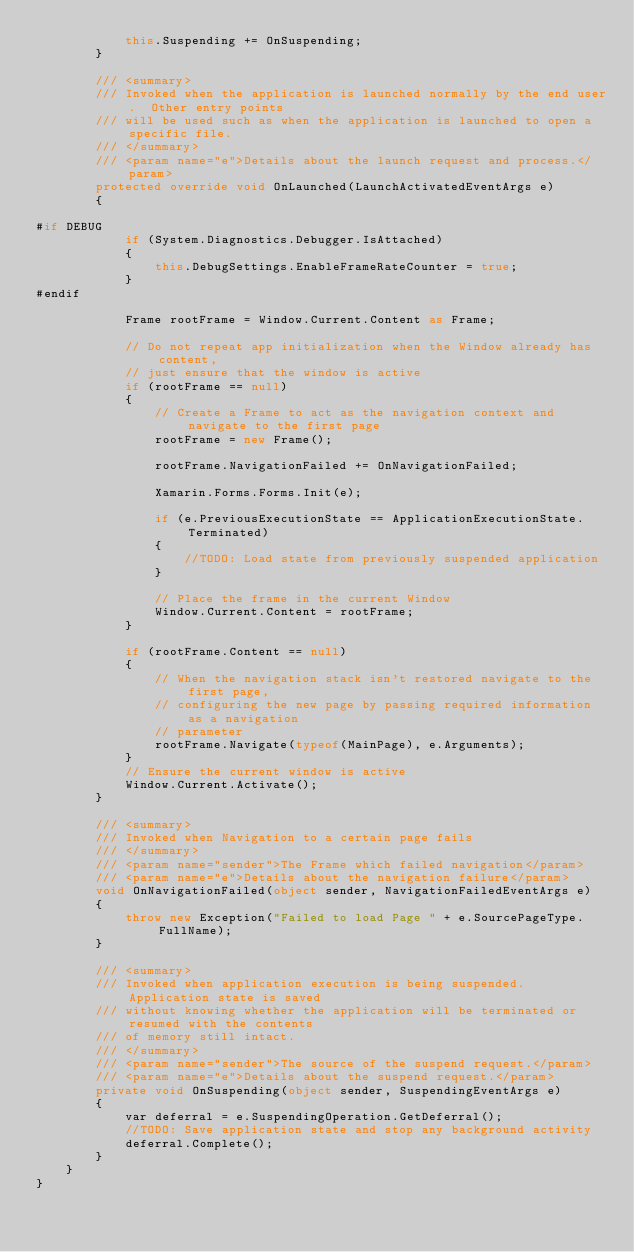Convert code to text. <code><loc_0><loc_0><loc_500><loc_500><_C#_>            this.Suspending += OnSuspending;
        }

        /// <summary>
        /// Invoked when the application is launched normally by the end user.  Other entry points
        /// will be used such as when the application is launched to open a specific file.
        /// </summary>
        /// <param name="e">Details about the launch request and process.</param>
        protected override void OnLaunched(LaunchActivatedEventArgs e)
        {

#if DEBUG
            if (System.Diagnostics.Debugger.IsAttached)
            {
                this.DebugSettings.EnableFrameRateCounter = true;
            }
#endif

            Frame rootFrame = Window.Current.Content as Frame;

            // Do not repeat app initialization when the Window already has content,
            // just ensure that the window is active
            if (rootFrame == null)
            {
                // Create a Frame to act as the navigation context and navigate to the first page
                rootFrame = new Frame();

                rootFrame.NavigationFailed += OnNavigationFailed;

                Xamarin.Forms.Forms.Init(e);

                if (e.PreviousExecutionState == ApplicationExecutionState.Terminated)
                {
                    //TODO: Load state from previously suspended application
                }

                // Place the frame in the current Window
                Window.Current.Content = rootFrame;
            }

            if (rootFrame.Content == null)
            {
                // When the navigation stack isn't restored navigate to the first page,
                // configuring the new page by passing required information as a navigation
                // parameter
                rootFrame.Navigate(typeof(MainPage), e.Arguments);
            }
            // Ensure the current window is active
            Window.Current.Activate();
        }

        /// <summary>
        /// Invoked when Navigation to a certain page fails
        /// </summary>
        /// <param name="sender">The Frame which failed navigation</param>
        /// <param name="e">Details about the navigation failure</param>
        void OnNavigationFailed(object sender, NavigationFailedEventArgs e)
        {
            throw new Exception("Failed to load Page " + e.SourcePageType.FullName);
        }

        /// <summary>
        /// Invoked when application execution is being suspended.  Application state is saved
        /// without knowing whether the application will be terminated or resumed with the contents
        /// of memory still intact.
        /// </summary>
        /// <param name="sender">The source of the suspend request.</param>
        /// <param name="e">Details about the suspend request.</param>
        private void OnSuspending(object sender, SuspendingEventArgs e)
        {
            var deferral = e.SuspendingOperation.GetDeferral();
            //TODO: Save application state and stop any background activity
            deferral.Complete();
        }
    }
}
</code> 